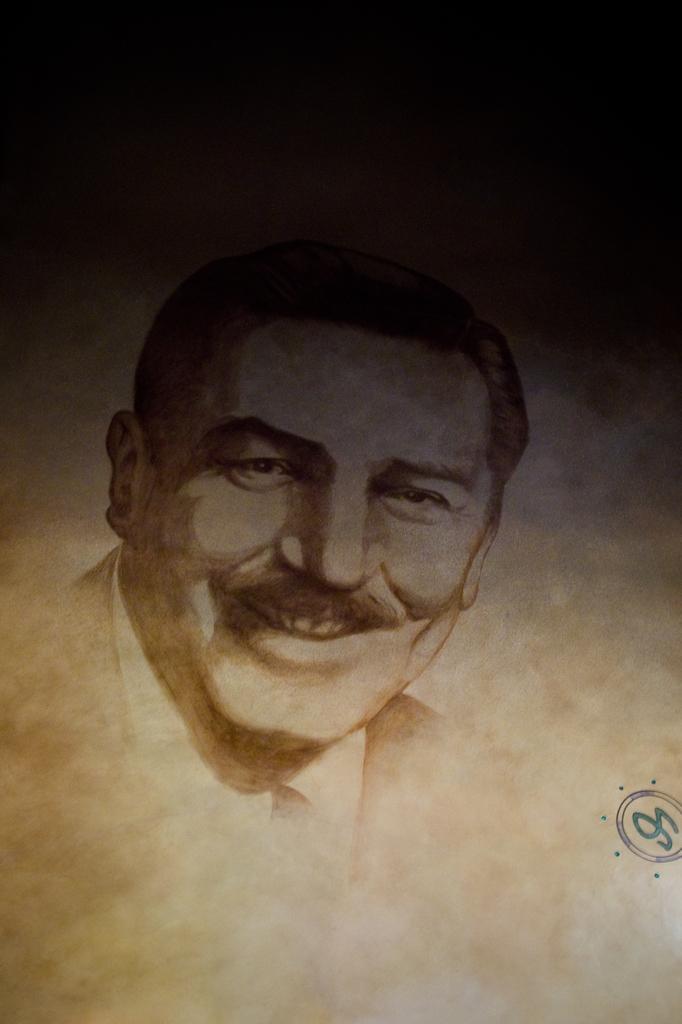Please provide a concise description of this image. In this image there is a painting of a person and there is a logo. 